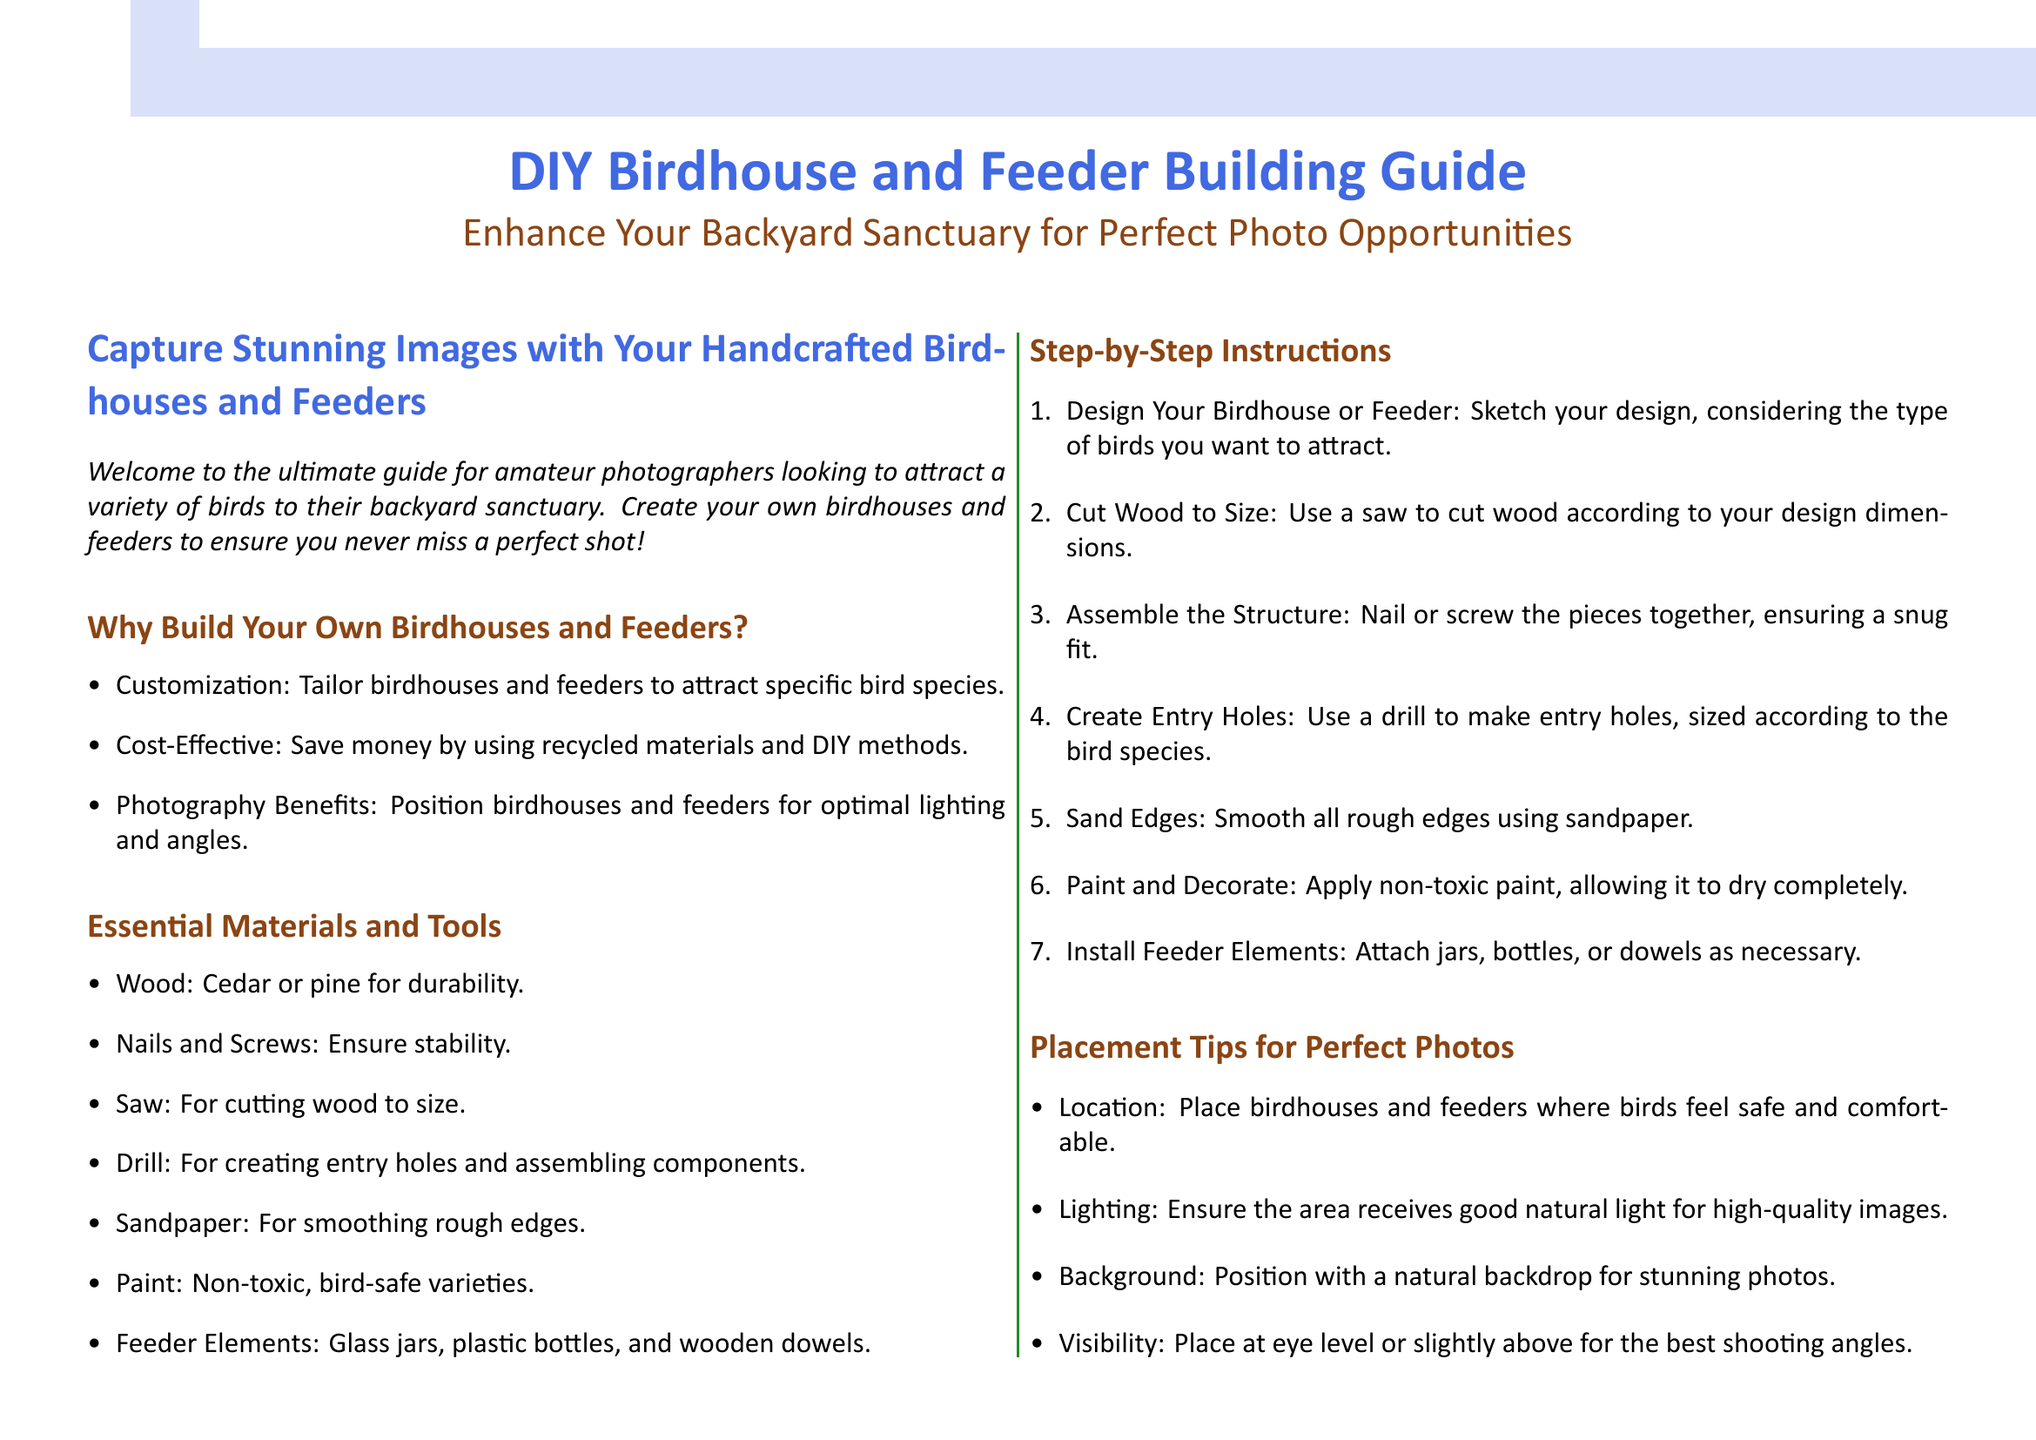What is the title of the document? The title is presented prominently at the top of the flyer, indicating the main subject of the guide.
Answer: DIY Birdhouse and Feeder Building Guide What color is used for the main heading? The color used for the main heading is specified in the document for visual appeal and emphasis.
Answer: Bird blue What is one type of wood recommended for building? The document lists specific materials needed for construction, highlighting suitable wood types.
Answer: Cedar How many steps are there in the building instructions? The instructions for building birdhouses and feeders are provided in a numbered list, indicating the total amount of steps.
Answer: Seven Which section suggests where to place birdhouses for the best photos? This section discusses optimal positioning for photography based on multiple considerations.
Answer: Placement Tips for Perfect Photos What is the purpose of sanding the edges? This step in the building instructions is aimed at ensuring safety and improving the finish of the birdhouses or feeders.
Answer: Smooth edges When should feeders be cleaned according to the maintenance section? The maintenance instructions recommend a specific frequency for cleaning feeders to ensure bird health.
Answer: Weekly What type of paint should be used? The guide specifies the type of paint that is safe and appropriate for use in constructing birdhouses and feeders.
Answer: Non-toxic, bird-safe varieties 